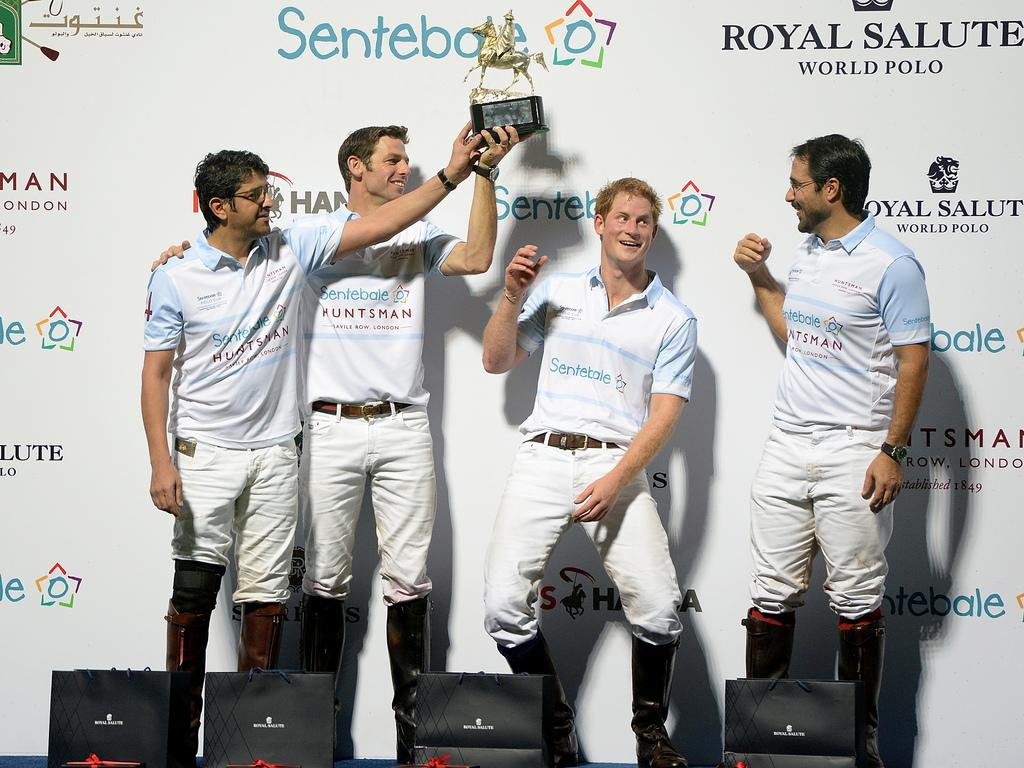<image>
Write a terse but informative summary of the picture. players for sentekale huntsman standing holding a trophy 